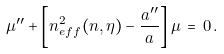<formula> <loc_0><loc_0><loc_500><loc_500>\mu ^ { \prime \prime } + \left [ n _ { e f f } ^ { 2 } ( n , \eta ) - { \frac { a ^ { \prime \prime } } { a } } \right ] \mu \, = \, 0 \, .</formula> 